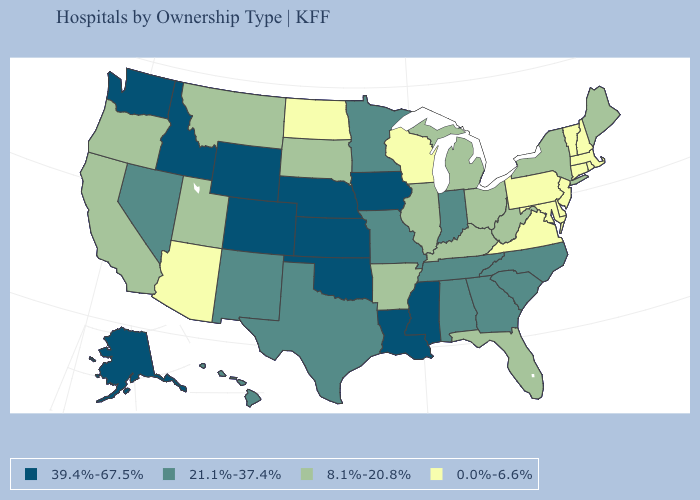What is the lowest value in the USA?
Answer briefly. 0.0%-6.6%. What is the value of New Mexico?
Write a very short answer. 21.1%-37.4%. Does New York have the same value as California?
Quick response, please. Yes. Name the states that have a value in the range 21.1%-37.4%?
Short answer required. Alabama, Georgia, Hawaii, Indiana, Minnesota, Missouri, Nevada, New Mexico, North Carolina, South Carolina, Tennessee, Texas. Name the states that have a value in the range 0.0%-6.6%?
Quick response, please. Arizona, Connecticut, Delaware, Maryland, Massachusetts, New Hampshire, New Jersey, North Dakota, Pennsylvania, Rhode Island, Vermont, Virginia, Wisconsin. What is the highest value in the USA?
Write a very short answer. 39.4%-67.5%. Among the states that border New Mexico , which have the lowest value?
Be succinct. Arizona. Which states hav the highest value in the MidWest?
Concise answer only. Iowa, Kansas, Nebraska. How many symbols are there in the legend?
Concise answer only. 4. Name the states that have a value in the range 21.1%-37.4%?
Keep it brief. Alabama, Georgia, Hawaii, Indiana, Minnesota, Missouri, Nevada, New Mexico, North Carolina, South Carolina, Tennessee, Texas. What is the value of Virginia?
Be succinct. 0.0%-6.6%. Name the states that have a value in the range 21.1%-37.4%?
Keep it brief. Alabama, Georgia, Hawaii, Indiana, Minnesota, Missouri, Nevada, New Mexico, North Carolina, South Carolina, Tennessee, Texas. What is the lowest value in the USA?
Keep it brief. 0.0%-6.6%. Name the states that have a value in the range 8.1%-20.8%?
Write a very short answer. Arkansas, California, Florida, Illinois, Kentucky, Maine, Michigan, Montana, New York, Ohio, Oregon, South Dakota, Utah, West Virginia. 